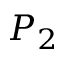<formula> <loc_0><loc_0><loc_500><loc_500>P _ { 2 }</formula> 